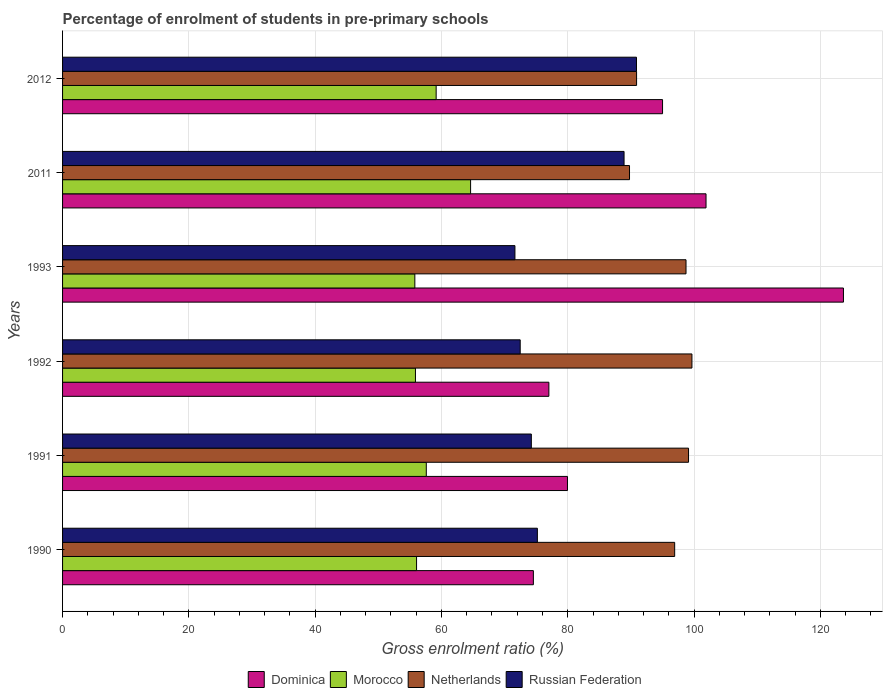How many groups of bars are there?
Give a very brief answer. 6. Are the number of bars per tick equal to the number of legend labels?
Your response must be concise. Yes. Are the number of bars on each tick of the Y-axis equal?
Give a very brief answer. Yes. How many bars are there on the 1st tick from the top?
Keep it short and to the point. 4. What is the label of the 3rd group of bars from the top?
Your answer should be compact. 1993. In how many cases, is the number of bars for a given year not equal to the number of legend labels?
Give a very brief answer. 0. What is the percentage of students enrolled in pre-primary schools in Morocco in 1991?
Make the answer very short. 57.6. Across all years, what is the maximum percentage of students enrolled in pre-primary schools in Russian Federation?
Offer a very short reply. 90.88. Across all years, what is the minimum percentage of students enrolled in pre-primary schools in Russian Federation?
Offer a very short reply. 71.64. What is the total percentage of students enrolled in pre-primary schools in Dominica in the graph?
Ensure brevity in your answer.  552.1. What is the difference between the percentage of students enrolled in pre-primary schools in Netherlands in 1990 and that in 2011?
Keep it short and to the point. 7.15. What is the difference between the percentage of students enrolled in pre-primary schools in Netherlands in 1993 and the percentage of students enrolled in pre-primary schools in Dominica in 1992?
Your answer should be very brief. 21.72. What is the average percentage of students enrolled in pre-primary schools in Dominica per year?
Offer a very short reply. 92.02. In the year 2011, what is the difference between the percentage of students enrolled in pre-primary schools in Morocco and percentage of students enrolled in pre-primary schools in Dominica?
Give a very brief answer. -37.28. What is the ratio of the percentage of students enrolled in pre-primary schools in Morocco in 1992 to that in 2011?
Your answer should be very brief. 0.86. What is the difference between the highest and the second highest percentage of students enrolled in pre-primary schools in Morocco?
Provide a succinct answer. 5.45. What is the difference between the highest and the lowest percentage of students enrolled in pre-primary schools in Dominica?
Provide a short and direct response. 49.1. In how many years, is the percentage of students enrolled in pre-primary schools in Russian Federation greater than the average percentage of students enrolled in pre-primary schools in Russian Federation taken over all years?
Make the answer very short. 2. Is the sum of the percentage of students enrolled in pre-primary schools in Russian Federation in 1993 and 2012 greater than the maximum percentage of students enrolled in pre-primary schools in Morocco across all years?
Give a very brief answer. Yes. What does the 4th bar from the top in 1992 represents?
Offer a terse response. Dominica. What does the 4th bar from the bottom in 1990 represents?
Offer a very short reply. Russian Federation. How many bars are there?
Offer a terse response. 24. What is the difference between two consecutive major ticks on the X-axis?
Keep it short and to the point. 20. Does the graph contain grids?
Your response must be concise. Yes. How many legend labels are there?
Keep it short and to the point. 4. What is the title of the graph?
Your answer should be very brief. Percentage of enrolment of students in pre-primary schools. Does "Low income" appear as one of the legend labels in the graph?
Offer a terse response. No. What is the Gross enrolment ratio (%) of Dominica in 1990?
Offer a terse response. 74.56. What is the Gross enrolment ratio (%) of Morocco in 1990?
Keep it short and to the point. 56.06. What is the Gross enrolment ratio (%) of Netherlands in 1990?
Offer a terse response. 96.93. What is the Gross enrolment ratio (%) of Russian Federation in 1990?
Your response must be concise. 75.19. What is the Gross enrolment ratio (%) of Dominica in 1991?
Your response must be concise. 79.96. What is the Gross enrolment ratio (%) of Morocco in 1991?
Provide a short and direct response. 57.6. What is the Gross enrolment ratio (%) in Netherlands in 1991?
Your response must be concise. 99.13. What is the Gross enrolment ratio (%) of Russian Federation in 1991?
Your response must be concise. 74.23. What is the Gross enrolment ratio (%) in Dominica in 1992?
Offer a terse response. 77.01. What is the Gross enrolment ratio (%) in Morocco in 1992?
Your response must be concise. 55.88. What is the Gross enrolment ratio (%) of Netherlands in 1992?
Ensure brevity in your answer.  99.67. What is the Gross enrolment ratio (%) of Russian Federation in 1992?
Offer a very short reply. 72.47. What is the Gross enrolment ratio (%) of Dominica in 1993?
Provide a short and direct response. 123.66. What is the Gross enrolment ratio (%) of Morocco in 1993?
Provide a short and direct response. 55.79. What is the Gross enrolment ratio (%) of Netherlands in 1993?
Ensure brevity in your answer.  98.73. What is the Gross enrolment ratio (%) in Russian Federation in 1993?
Give a very brief answer. 71.64. What is the Gross enrolment ratio (%) in Dominica in 2011?
Make the answer very short. 101.9. What is the Gross enrolment ratio (%) of Morocco in 2011?
Provide a short and direct response. 64.61. What is the Gross enrolment ratio (%) in Netherlands in 2011?
Provide a succinct answer. 89.78. What is the Gross enrolment ratio (%) of Russian Federation in 2011?
Your answer should be very brief. 88.92. What is the Gross enrolment ratio (%) of Dominica in 2012?
Your answer should be compact. 95.01. What is the Gross enrolment ratio (%) of Morocco in 2012?
Your answer should be very brief. 59.16. What is the Gross enrolment ratio (%) of Netherlands in 2012?
Keep it short and to the point. 90.9. What is the Gross enrolment ratio (%) of Russian Federation in 2012?
Make the answer very short. 90.88. Across all years, what is the maximum Gross enrolment ratio (%) in Dominica?
Ensure brevity in your answer.  123.66. Across all years, what is the maximum Gross enrolment ratio (%) of Morocco?
Offer a very short reply. 64.61. Across all years, what is the maximum Gross enrolment ratio (%) in Netherlands?
Offer a very short reply. 99.67. Across all years, what is the maximum Gross enrolment ratio (%) of Russian Federation?
Offer a very short reply. 90.88. Across all years, what is the minimum Gross enrolment ratio (%) in Dominica?
Your answer should be compact. 74.56. Across all years, what is the minimum Gross enrolment ratio (%) of Morocco?
Offer a terse response. 55.79. Across all years, what is the minimum Gross enrolment ratio (%) in Netherlands?
Ensure brevity in your answer.  89.78. Across all years, what is the minimum Gross enrolment ratio (%) of Russian Federation?
Your answer should be compact. 71.64. What is the total Gross enrolment ratio (%) in Dominica in the graph?
Provide a short and direct response. 552.1. What is the total Gross enrolment ratio (%) of Morocco in the graph?
Your answer should be very brief. 349.11. What is the total Gross enrolment ratio (%) in Netherlands in the graph?
Give a very brief answer. 575.14. What is the total Gross enrolment ratio (%) in Russian Federation in the graph?
Keep it short and to the point. 473.34. What is the difference between the Gross enrolment ratio (%) of Dominica in 1990 and that in 1991?
Keep it short and to the point. -5.4. What is the difference between the Gross enrolment ratio (%) in Morocco in 1990 and that in 1991?
Make the answer very short. -1.54. What is the difference between the Gross enrolment ratio (%) in Netherlands in 1990 and that in 1991?
Your answer should be compact. -2.2. What is the difference between the Gross enrolment ratio (%) in Russian Federation in 1990 and that in 1991?
Your answer should be compact. 0.96. What is the difference between the Gross enrolment ratio (%) of Dominica in 1990 and that in 1992?
Provide a succinct answer. -2.45. What is the difference between the Gross enrolment ratio (%) in Morocco in 1990 and that in 1992?
Ensure brevity in your answer.  0.18. What is the difference between the Gross enrolment ratio (%) in Netherlands in 1990 and that in 1992?
Ensure brevity in your answer.  -2.73. What is the difference between the Gross enrolment ratio (%) of Russian Federation in 1990 and that in 1992?
Your answer should be very brief. 2.72. What is the difference between the Gross enrolment ratio (%) of Dominica in 1990 and that in 1993?
Make the answer very short. -49.1. What is the difference between the Gross enrolment ratio (%) in Morocco in 1990 and that in 1993?
Keep it short and to the point. 0.27. What is the difference between the Gross enrolment ratio (%) of Netherlands in 1990 and that in 1993?
Provide a succinct answer. -1.8. What is the difference between the Gross enrolment ratio (%) of Russian Federation in 1990 and that in 1993?
Your response must be concise. 3.55. What is the difference between the Gross enrolment ratio (%) of Dominica in 1990 and that in 2011?
Your response must be concise. -27.34. What is the difference between the Gross enrolment ratio (%) in Morocco in 1990 and that in 2011?
Ensure brevity in your answer.  -8.55. What is the difference between the Gross enrolment ratio (%) in Netherlands in 1990 and that in 2011?
Provide a succinct answer. 7.15. What is the difference between the Gross enrolment ratio (%) in Russian Federation in 1990 and that in 2011?
Your response must be concise. -13.73. What is the difference between the Gross enrolment ratio (%) of Dominica in 1990 and that in 2012?
Offer a very short reply. -20.46. What is the difference between the Gross enrolment ratio (%) of Morocco in 1990 and that in 2012?
Give a very brief answer. -3.1. What is the difference between the Gross enrolment ratio (%) of Netherlands in 1990 and that in 2012?
Offer a very short reply. 6.03. What is the difference between the Gross enrolment ratio (%) in Russian Federation in 1990 and that in 2012?
Provide a short and direct response. -15.69. What is the difference between the Gross enrolment ratio (%) in Dominica in 1991 and that in 1992?
Your answer should be compact. 2.95. What is the difference between the Gross enrolment ratio (%) in Morocco in 1991 and that in 1992?
Ensure brevity in your answer.  1.72. What is the difference between the Gross enrolment ratio (%) of Netherlands in 1991 and that in 1992?
Provide a short and direct response. -0.54. What is the difference between the Gross enrolment ratio (%) of Russian Federation in 1991 and that in 1992?
Provide a succinct answer. 1.76. What is the difference between the Gross enrolment ratio (%) of Dominica in 1991 and that in 1993?
Provide a short and direct response. -43.7. What is the difference between the Gross enrolment ratio (%) in Morocco in 1991 and that in 1993?
Your response must be concise. 1.81. What is the difference between the Gross enrolment ratio (%) in Netherlands in 1991 and that in 1993?
Keep it short and to the point. 0.4. What is the difference between the Gross enrolment ratio (%) of Russian Federation in 1991 and that in 1993?
Provide a short and direct response. 2.6. What is the difference between the Gross enrolment ratio (%) in Dominica in 1991 and that in 2011?
Give a very brief answer. -21.94. What is the difference between the Gross enrolment ratio (%) of Morocco in 1991 and that in 2011?
Your answer should be compact. -7.01. What is the difference between the Gross enrolment ratio (%) in Netherlands in 1991 and that in 2011?
Offer a terse response. 9.35. What is the difference between the Gross enrolment ratio (%) of Russian Federation in 1991 and that in 2011?
Offer a very short reply. -14.68. What is the difference between the Gross enrolment ratio (%) of Dominica in 1991 and that in 2012?
Ensure brevity in your answer.  -15.06. What is the difference between the Gross enrolment ratio (%) in Morocco in 1991 and that in 2012?
Make the answer very short. -1.56. What is the difference between the Gross enrolment ratio (%) of Netherlands in 1991 and that in 2012?
Your answer should be very brief. 8.23. What is the difference between the Gross enrolment ratio (%) in Russian Federation in 1991 and that in 2012?
Offer a terse response. -16.65. What is the difference between the Gross enrolment ratio (%) of Dominica in 1992 and that in 1993?
Your response must be concise. -46.65. What is the difference between the Gross enrolment ratio (%) of Morocco in 1992 and that in 1993?
Your response must be concise. 0.09. What is the difference between the Gross enrolment ratio (%) of Netherlands in 1992 and that in 1993?
Offer a terse response. 0.94. What is the difference between the Gross enrolment ratio (%) in Russian Federation in 1992 and that in 1993?
Keep it short and to the point. 0.84. What is the difference between the Gross enrolment ratio (%) in Dominica in 1992 and that in 2011?
Make the answer very short. -24.89. What is the difference between the Gross enrolment ratio (%) in Morocco in 1992 and that in 2011?
Offer a terse response. -8.73. What is the difference between the Gross enrolment ratio (%) of Netherlands in 1992 and that in 2011?
Keep it short and to the point. 9.89. What is the difference between the Gross enrolment ratio (%) in Russian Federation in 1992 and that in 2011?
Your response must be concise. -16.45. What is the difference between the Gross enrolment ratio (%) of Dominica in 1992 and that in 2012?
Give a very brief answer. -18. What is the difference between the Gross enrolment ratio (%) of Morocco in 1992 and that in 2012?
Keep it short and to the point. -3.28. What is the difference between the Gross enrolment ratio (%) in Netherlands in 1992 and that in 2012?
Offer a very short reply. 8.77. What is the difference between the Gross enrolment ratio (%) in Russian Federation in 1992 and that in 2012?
Provide a succinct answer. -18.41. What is the difference between the Gross enrolment ratio (%) in Dominica in 1993 and that in 2011?
Ensure brevity in your answer.  21.76. What is the difference between the Gross enrolment ratio (%) in Morocco in 1993 and that in 2011?
Your answer should be very brief. -8.83. What is the difference between the Gross enrolment ratio (%) in Netherlands in 1993 and that in 2011?
Offer a terse response. 8.95. What is the difference between the Gross enrolment ratio (%) in Russian Federation in 1993 and that in 2011?
Offer a very short reply. -17.28. What is the difference between the Gross enrolment ratio (%) in Dominica in 1993 and that in 2012?
Provide a succinct answer. 28.65. What is the difference between the Gross enrolment ratio (%) in Morocco in 1993 and that in 2012?
Give a very brief answer. -3.38. What is the difference between the Gross enrolment ratio (%) of Netherlands in 1993 and that in 2012?
Offer a terse response. 7.83. What is the difference between the Gross enrolment ratio (%) of Russian Federation in 1993 and that in 2012?
Your answer should be very brief. -19.25. What is the difference between the Gross enrolment ratio (%) in Dominica in 2011 and that in 2012?
Give a very brief answer. 6.89. What is the difference between the Gross enrolment ratio (%) of Morocco in 2011 and that in 2012?
Provide a succinct answer. 5.45. What is the difference between the Gross enrolment ratio (%) of Netherlands in 2011 and that in 2012?
Your answer should be very brief. -1.12. What is the difference between the Gross enrolment ratio (%) of Russian Federation in 2011 and that in 2012?
Provide a short and direct response. -1.97. What is the difference between the Gross enrolment ratio (%) of Dominica in 1990 and the Gross enrolment ratio (%) of Morocco in 1991?
Make the answer very short. 16.96. What is the difference between the Gross enrolment ratio (%) of Dominica in 1990 and the Gross enrolment ratio (%) of Netherlands in 1991?
Your answer should be compact. -24.57. What is the difference between the Gross enrolment ratio (%) in Dominica in 1990 and the Gross enrolment ratio (%) in Russian Federation in 1991?
Your answer should be very brief. 0.32. What is the difference between the Gross enrolment ratio (%) in Morocco in 1990 and the Gross enrolment ratio (%) in Netherlands in 1991?
Give a very brief answer. -43.07. What is the difference between the Gross enrolment ratio (%) in Morocco in 1990 and the Gross enrolment ratio (%) in Russian Federation in 1991?
Keep it short and to the point. -18.17. What is the difference between the Gross enrolment ratio (%) in Netherlands in 1990 and the Gross enrolment ratio (%) in Russian Federation in 1991?
Provide a short and direct response. 22.7. What is the difference between the Gross enrolment ratio (%) in Dominica in 1990 and the Gross enrolment ratio (%) in Morocco in 1992?
Provide a short and direct response. 18.68. What is the difference between the Gross enrolment ratio (%) of Dominica in 1990 and the Gross enrolment ratio (%) of Netherlands in 1992?
Your answer should be compact. -25.11. What is the difference between the Gross enrolment ratio (%) in Dominica in 1990 and the Gross enrolment ratio (%) in Russian Federation in 1992?
Ensure brevity in your answer.  2.09. What is the difference between the Gross enrolment ratio (%) in Morocco in 1990 and the Gross enrolment ratio (%) in Netherlands in 1992?
Offer a very short reply. -43.61. What is the difference between the Gross enrolment ratio (%) in Morocco in 1990 and the Gross enrolment ratio (%) in Russian Federation in 1992?
Offer a very short reply. -16.41. What is the difference between the Gross enrolment ratio (%) of Netherlands in 1990 and the Gross enrolment ratio (%) of Russian Federation in 1992?
Keep it short and to the point. 24.46. What is the difference between the Gross enrolment ratio (%) of Dominica in 1990 and the Gross enrolment ratio (%) of Morocco in 1993?
Provide a succinct answer. 18.77. What is the difference between the Gross enrolment ratio (%) of Dominica in 1990 and the Gross enrolment ratio (%) of Netherlands in 1993?
Your response must be concise. -24.17. What is the difference between the Gross enrolment ratio (%) of Dominica in 1990 and the Gross enrolment ratio (%) of Russian Federation in 1993?
Your answer should be very brief. 2.92. What is the difference between the Gross enrolment ratio (%) in Morocco in 1990 and the Gross enrolment ratio (%) in Netherlands in 1993?
Offer a very short reply. -42.67. What is the difference between the Gross enrolment ratio (%) of Morocco in 1990 and the Gross enrolment ratio (%) of Russian Federation in 1993?
Provide a short and direct response. -15.58. What is the difference between the Gross enrolment ratio (%) in Netherlands in 1990 and the Gross enrolment ratio (%) in Russian Federation in 1993?
Your response must be concise. 25.3. What is the difference between the Gross enrolment ratio (%) of Dominica in 1990 and the Gross enrolment ratio (%) of Morocco in 2011?
Your answer should be very brief. 9.94. What is the difference between the Gross enrolment ratio (%) of Dominica in 1990 and the Gross enrolment ratio (%) of Netherlands in 2011?
Your answer should be very brief. -15.22. What is the difference between the Gross enrolment ratio (%) in Dominica in 1990 and the Gross enrolment ratio (%) in Russian Federation in 2011?
Your answer should be very brief. -14.36. What is the difference between the Gross enrolment ratio (%) of Morocco in 1990 and the Gross enrolment ratio (%) of Netherlands in 2011?
Offer a terse response. -33.72. What is the difference between the Gross enrolment ratio (%) of Morocco in 1990 and the Gross enrolment ratio (%) of Russian Federation in 2011?
Provide a short and direct response. -32.86. What is the difference between the Gross enrolment ratio (%) in Netherlands in 1990 and the Gross enrolment ratio (%) in Russian Federation in 2011?
Ensure brevity in your answer.  8.02. What is the difference between the Gross enrolment ratio (%) of Dominica in 1990 and the Gross enrolment ratio (%) of Morocco in 2012?
Offer a very short reply. 15.4. What is the difference between the Gross enrolment ratio (%) of Dominica in 1990 and the Gross enrolment ratio (%) of Netherlands in 2012?
Provide a short and direct response. -16.34. What is the difference between the Gross enrolment ratio (%) in Dominica in 1990 and the Gross enrolment ratio (%) in Russian Federation in 2012?
Make the answer very short. -16.33. What is the difference between the Gross enrolment ratio (%) in Morocco in 1990 and the Gross enrolment ratio (%) in Netherlands in 2012?
Offer a very short reply. -34.84. What is the difference between the Gross enrolment ratio (%) in Morocco in 1990 and the Gross enrolment ratio (%) in Russian Federation in 2012?
Your answer should be compact. -34.82. What is the difference between the Gross enrolment ratio (%) of Netherlands in 1990 and the Gross enrolment ratio (%) of Russian Federation in 2012?
Offer a very short reply. 6.05. What is the difference between the Gross enrolment ratio (%) in Dominica in 1991 and the Gross enrolment ratio (%) in Morocco in 1992?
Provide a succinct answer. 24.07. What is the difference between the Gross enrolment ratio (%) in Dominica in 1991 and the Gross enrolment ratio (%) in Netherlands in 1992?
Offer a very short reply. -19.71. What is the difference between the Gross enrolment ratio (%) in Dominica in 1991 and the Gross enrolment ratio (%) in Russian Federation in 1992?
Your answer should be compact. 7.49. What is the difference between the Gross enrolment ratio (%) of Morocco in 1991 and the Gross enrolment ratio (%) of Netherlands in 1992?
Your response must be concise. -42.07. What is the difference between the Gross enrolment ratio (%) in Morocco in 1991 and the Gross enrolment ratio (%) in Russian Federation in 1992?
Offer a very short reply. -14.87. What is the difference between the Gross enrolment ratio (%) in Netherlands in 1991 and the Gross enrolment ratio (%) in Russian Federation in 1992?
Keep it short and to the point. 26.66. What is the difference between the Gross enrolment ratio (%) in Dominica in 1991 and the Gross enrolment ratio (%) in Morocco in 1993?
Provide a succinct answer. 24.17. What is the difference between the Gross enrolment ratio (%) of Dominica in 1991 and the Gross enrolment ratio (%) of Netherlands in 1993?
Offer a terse response. -18.77. What is the difference between the Gross enrolment ratio (%) in Dominica in 1991 and the Gross enrolment ratio (%) in Russian Federation in 1993?
Your answer should be very brief. 8.32. What is the difference between the Gross enrolment ratio (%) of Morocco in 1991 and the Gross enrolment ratio (%) of Netherlands in 1993?
Provide a succinct answer. -41.13. What is the difference between the Gross enrolment ratio (%) in Morocco in 1991 and the Gross enrolment ratio (%) in Russian Federation in 1993?
Your answer should be very brief. -14.03. What is the difference between the Gross enrolment ratio (%) in Netherlands in 1991 and the Gross enrolment ratio (%) in Russian Federation in 1993?
Provide a short and direct response. 27.49. What is the difference between the Gross enrolment ratio (%) of Dominica in 1991 and the Gross enrolment ratio (%) of Morocco in 2011?
Offer a very short reply. 15.34. What is the difference between the Gross enrolment ratio (%) in Dominica in 1991 and the Gross enrolment ratio (%) in Netherlands in 2011?
Your response must be concise. -9.82. What is the difference between the Gross enrolment ratio (%) of Dominica in 1991 and the Gross enrolment ratio (%) of Russian Federation in 2011?
Keep it short and to the point. -8.96. What is the difference between the Gross enrolment ratio (%) of Morocco in 1991 and the Gross enrolment ratio (%) of Netherlands in 2011?
Your answer should be very brief. -32.18. What is the difference between the Gross enrolment ratio (%) of Morocco in 1991 and the Gross enrolment ratio (%) of Russian Federation in 2011?
Offer a terse response. -31.32. What is the difference between the Gross enrolment ratio (%) of Netherlands in 1991 and the Gross enrolment ratio (%) of Russian Federation in 2011?
Your answer should be very brief. 10.21. What is the difference between the Gross enrolment ratio (%) in Dominica in 1991 and the Gross enrolment ratio (%) in Morocco in 2012?
Your answer should be very brief. 20.79. What is the difference between the Gross enrolment ratio (%) in Dominica in 1991 and the Gross enrolment ratio (%) in Netherlands in 2012?
Make the answer very short. -10.94. What is the difference between the Gross enrolment ratio (%) in Dominica in 1991 and the Gross enrolment ratio (%) in Russian Federation in 2012?
Provide a succinct answer. -10.93. What is the difference between the Gross enrolment ratio (%) of Morocco in 1991 and the Gross enrolment ratio (%) of Netherlands in 2012?
Your response must be concise. -33.3. What is the difference between the Gross enrolment ratio (%) of Morocco in 1991 and the Gross enrolment ratio (%) of Russian Federation in 2012?
Keep it short and to the point. -33.28. What is the difference between the Gross enrolment ratio (%) of Netherlands in 1991 and the Gross enrolment ratio (%) of Russian Federation in 2012?
Your answer should be compact. 8.24. What is the difference between the Gross enrolment ratio (%) in Dominica in 1992 and the Gross enrolment ratio (%) in Morocco in 1993?
Your response must be concise. 21.22. What is the difference between the Gross enrolment ratio (%) in Dominica in 1992 and the Gross enrolment ratio (%) in Netherlands in 1993?
Provide a succinct answer. -21.72. What is the difference between the Gross enrolment ratio (%) of Dominica in 1992 and the Gross enrolment ratio (%) of Russian Federation in 1993?
Make the answer very short. 5.38. What is the difference between the Gross enrolment ratio (%) in Morocco in 1992 and the Gross enrolment ratio (%) in Netherlands in 1993?
Provide a short and direct response. -42.85. What is the difference between the Gross enrolment ratio (%) in Morocco in 1992 and the Gross enrolment ratio (%) in Russian Federation in 1993?
Ensure brevity in your answer.  -15.75. What is the difference between the Gross enrolment ratio (%) in Netherlands in 1992 and the Gross enrolment ratio (%) in Russian Federation in 1993?
Offer a very short reply. 28.03. What is the difference between the Gross enrolment ratio (%) in Dominica in 1992 and the Gross enrolment ratio (%) in Morocco in 2011?
Your answer should be compact. 12.4. What is the difference between the Gross enrolment ratio (%) of Dominica in 1992 and the Gross enrolment ratio (%) of Netherlands in 2011?
Your answer should be very brief. -12.77. What is the difference between the Gross enrolment ratio (%) in Dominica in 1992 and the Gross enrolment ratio (%) in Russian Federation in 2011?
Provide a succinct answer. -11.91. What is the difference between the Gross enrolment ratio (%) in Morocco in 1992 and the Gross enrolment ratio (%) in Netherlands in 2011?
Ensure brevity in your answer.  -33.9. What is the difference between the Gross enrolment ratio (%) of Morocco in 1992 and the Gross enrolment ratio (%) of Russian Federation in 2011?
Your answer should be very brief. -33.03. What is the difference between the Gross enrolment ratio (%) in Netherlands in 1992 and the Gross enrolment ratio (%) in Russian Federation in 2011?
Your answer should be very brief. 10.75. What is the difference between the Gross enrolment ratio (%) of Dominica in 1992 and the Gross enrolment ratio (%) of Morocco in 2012?
Your answer should be compact. 17.85. What is the difference between the Gross enrolment ratio (%) in Dominica in 1992 and the Gross enrolment ratio (%) in Netherlands in 2012?
Ensure brevity in your answer.  -13.89. What is the difference between the Gross enrolment ratio (%) of Dominica in 1992 and the Gross enrolment ratio (%) of Russian Federation in 2012?
Your response must be concise. -13.87. What is the difference between the Gross enrolment ratio (%) of Morocco in 1992 and the Gross enrolment ratio (%) of Netherlands in 2012?
Keep it short and to the point. -35.02. What is the difference between the Gross enrolment ratio (%) in Morocco in 1992 and the Gross enrolment ratio (%) in Russian Federation in 2012?
Provide a succinct answer. -35. What is the difference between the Gross enrolment ratio (%) in Netherlands in 1992 and the Gross enrolment ratio (%) in Russian Federation in 2012?
Provide a short and direct response. 8.78. What is the difference between the Gross enrolment ratio (%) of Dominica in 1993 and the Gross enrolment ratio (%) of Morocco in 2011?
Ensure brevity in your answer.  59.05. What is the difference between the Gross enrolment ratio (%) of Dominica in 1993 and the Gross enrolment ratio (%) of Netherlands in 2011?
Give a very brief answer. 33.88. What is the difference between the Gross enrolment ratio (%) of Dominica in 1993 and the Gross enrolment ratio (%) of Russian Federation in 2011?
Offer a terse response. 34.74. What is the difference between the Gross enrolment ratio (%) in Morocco in 1993 and the Gross enrolment ratio (%) in Netherlands in 2011?
Your answer should be compact. -33.99. What is the difference between the Gross enrolment ratio (%) of Morocco in 1993 and the Gross enrolment ratio (%) of Russian Federation in 2011?
Make the answer very short. -33.13. What is the difference between the Gross enrolment ratio (%) of Netherlands in 1993 and the Gross enrolment ratio (%) of Russian Federation in 2011?
Provide a short and direct response. 9.81. What is the difference between the Gross enrolment ratio (%) of Dominica in 1993 and the Gross enrolment ratio (%) of Morocco in 2012?
Your response must be concise. 64.5. What is the difference between the Gross enrolment ratio (%) in Dominica in 1993 and the Gross enrolment ratio (%) in Netherlands in 2012?
Offer a very short reply. 32.76. What is the difference between the Gross enrolment ratio (%) of Dominica in 1993 and the Gross enrolment ratio (%) of Russian Federation in 2012?
Your answer should be very brief. 32.78. What is the difference between the Gross enrolment ratio (%) in Morocco in 1993 and the Gross enrolment ratio (%) in Netherlands in 2012?
Make the answer very short. -35.11. What is the difference between the Gross enrolment ratio (%) of Morocco in 1993 and the Gross enrolment ratio (%) of Russian Federation in 2012?
Give a very brief answer. -35.1. What is the difference between the Gross enrolment ratio (%) of Netherlands in 1993 and the Gross enrolment ratio (%) of Russian Federation in 2012?
Ensure brevity in your answer.  7.85. What is the difference between the Gross enrolment ratio (%) of Dominica in 2011 and the Gross enrolment ratio (%) of Morocco in 2012?
Provide a short and direct response. 42.74. What is the difference between the Gross enrolment ratio (%) in Dominica in 2011 and the Gross enrolment ratio (%) in Netherlands in 2012?
Your answer should be very brief. 11. What is the difference between the Gross enrolment ratio (%) in Dominica in 2011 and the Gross enrolment ratio (%) in Russian Federation in 2012?
Offer a terse response. 11.01. What is the difference between the Gross enrolment ratio (%) of Morocco in 2011 and the Gross enrolment ratio (%) of Netherlands in 2012?
Your response must be concise. -26.28. What is the difference between the Gross enrolment ratio (%) in Morocco in 2011 and the Gross enrolment ratio (%) in Russian Federation in 2012?
Keep it short and to the point. -26.27. What is the difference between the Gross enrolment ratio (%) of Netherlands in 2011 and the Gross enrolment ratio (%) of Russian Federation in 2012?
Give a very brief answer. -1.1. What is the average Gross enrolment ratio (%) of Dominica per year?
Provide a succinct answer. 92.02. What is the average Gross enrolment ratio (%) in Morocco per year?
Provide a succinct answer. 58.18. What is the average Gross enrolment ratio (%) of Netherlands per year?
Offer a very short reply. 95.86. What is the average Gross enrolment ratio (%) in Russian Federation per year?
Your answer should be very brief. 78.89. In the year 1990, what is the difference between the Gross enrolment ratio (%) in Dominica and Gross enrolment ratio (%) in Morocco?
Offer a very short reply. 18.5. In the year 1990, what is the difference between the Gross enrolment ratio (%) of Dominica and Gross enrolment ratio (%) of Netherlands?
Give a very brief answer. -22.38. In the year 1990, what is the difference between the Gross enrolment ratio (%) in Dominica and Gross enrolment ratio (%) in Russian Federation?
Your response must be concise. -0.63. In the year 1990, what is the difference between the Gross enrolment ratio (%) of Morocco and Gross enrolment ratio (%) of Netherlands?
Offer a very short reply. -40.87. In the year 1990, what is the difference between the Gross enrolment ratio (%) of Morocco and Gross enrolment ratio (%) of Russian Federation?
Ensure brevity in your answer.  -19.13. In the year 1990, what is the difference between the Gross enrolment ratio (%) in Netherlands and Gross enrolment ratio (%) in Russian Federation?
Provide a short and direct response. 21.74. In the year 1991, what is the difference between the Gross enrolment ratio (%) in Dominica and Gross enrolment ratio (%) in Morocco?
Keep it short and to the point. 22.36. In the year 1991, what is the difference between the Gross enrolment ratio (%) of Dominica and Gross enrolment ratio (%) of Netherlands?
Give a very brief answer. -19.17. In the year 1991, what is the difference between the Gross enrolment ratio (%) of Dominica and Gross enrolment ratio (%) of Russian Federation?
Ensure brevity in your answer.  5.72. In the year 1991, what is the difference between the Gross enrolment ratio (%) of Morocco and Gross enrolment ratio (%) of Netherlands?
Your answer should be very brief. -41.53. In the year 1991, what is the difference between the Gross enrolment ratio (%) of Morocco and Gross enrolment ratio (%) of Russian Federation?
Offer a terse response. -16.63. In the year 1991, what is the difference between the Gross enrolment ratio (%) in Netherlands and Gross enrolment ratio (%) in Russian Federation?
Your response must be concise. 24.89. In the year 1992, what is the difference between the Gross enrolment ratio (%) in Dominica and Gross enrolment ratio (%) in Morocco?
Provide a succinct answer. 21.13. In the year 1992, what is the difference between the Gross enrolment ratio (%) of Dominica and Gross enrolment ratio (%) of Netherlands?
Your answer should be compact. -22.66. In the year 1992, what is the difference between the Gross enrolment ratio (%) in Dominica and Gross enrolment ratio (%) in Russian Federation?
Provide a succinct answer. 4.54. In the year 1992, what is the difference between the Gross enrolment ratio (%) of Morocco and Gross enrolment ratio (%) of Netherlands?
Keep it short and to the point. -43.78. In the year 1992, what is the difference between the Gross enrolment ratio (%) of Morocco and Gross enrolment ratio (%) of Russian Federation?
Make the answer very short. -16.59. In the year 1992, what is the difference between the Gross enrolment ratio (%) in Netherlands and Gross enrolment ratio (%) in Russian Federation?
Provide a short and direct response. 27.2. In the year 1993, what is the difference between the Gross enrolment ratio (%) in Dominica and Gross enrolment ratio (%) in Morocco?
Make the answer very short. 67.87. In the year 1993, what is the difference between the Gross enrolment ratio (%) in Dominica and Gross enrolment ratio (%) in Netherlands?
Offer a very short reply. 24.93. In the year 1993, what is the difference between the Gross enrolment ratio (%) in Dominica and Gross enrolment ratio (%) in Russian Federation?
Provide a succinct answer. 52.02. In the year 1993, what is the difference between the Gross enrolment ratio (%) in Morocco and Gross enrolment ratio (%) in Netherlands?
Offer a terse response. -42.94. In the year 1993, what is the difference between the Gross enrolment ratio (%) in Morocco and Gross enrolment ratio (%) in Russian Federation?
Offer a terse response. -15.85. In the year 1993, what is the difference between the Gross enrolment ratio (%) of Netherlands and Gross enrolment ratio (%) of Russian Federation?
Ensure brevity in your answer.  27.09. In the year 2011, what is the difference between the Gross enrolment ratio (%) of Dominica and Gross enrolment ratio (%) of Morocco?
Offer a very short reply. 37.28. In the year 2011, what is the difference between the Gross enrolment ratio (%) in Dominica and Gross enrolment ratio (%) in Netherlands?
Your response must be concise. 12.12. In the year 2011, what is the difference between the Gross enrolment ratio (%) in Dominica and Gross enrolment ratio (%) in Russian Federation?
Your response must be concise. 12.98. In the year 2011, what is the difference between the Gross enrolment ratio (%) in Morocco and Gross enrolment ratio (%) in Netherlands?
Your answer should be very brief. -25.17. In the year 2011, what is the difference between the Gross enrolment ratio (%) in Morocco and Gross enrolment ratio (%) in Russian Federation?
Give a very brief answer. -24.3. In the year 2011, what is the difference between the Gross enrolment ratio (%) of Netherlands and Gross enrolment ratio (%) of Russian Federation?
Your answer should be compact. 0.86. In the year 2012, what is the difference between the Gross enrolment ratio (%) in Dominica and Gross enrolment ratio (%) in Morocco?
Give a very brief answer. 35.85. In the year 2012, what is the difference between the Gross enrolment ratio (%) of Dominica and Gross enrolment ratio (%) of Netherlands?
Offer a very short reply. 4.11. In the year 2012, what is the difference between the Gross enrolment ratio (%) in Dominica and Gross enrolment ratio (%) in Russian Federation?
Your answer should be very brief. 4.13. In the year 2012, what is the difference between the Gross enrolment ratio (%) in Morocco and Gross enrolment ratio (%) in Netherlands?
Ensure brevity in your answer.  -31.74. In the year 2012, what is the difference between the Gross enrolment ratio (%) in Morocco and Gross enrolment ratio (%) in Russian Federation?
Ensure brevity in your answer.  -31.72. In the year 2012, what is the difference between the Gross enrolment ratio (%) of Netherlands and Gross enrolment ratio (%) of Russian Federation?
Offer a terse response. 0.01. What is the ratio of the Gross enrolment ratio (%) of Dominica in 1990 to that in 1991?
Keep it short and to the point. 0.93. What is the ratio of the Gross enrolment ratio (%) in Morocco in 1990 to that in 1991?
Provide a succinct answer. 0.97. What is the ratio of the Gross enrolment ratio (%) of Netherlands in 1990 to that in 1991?
Your answer should be compact. 0.98. What is the ratio of the Gross enrolment ratio (%) of Russian Federation in 1990 to that in 1991?
Your response must be concise. 1.01. What is the ratio of the Gross enrolment ratio (%) in Dominica in 1990 to that in 1992?
Your answer should be very brief. 0.97. What is the ratio of the Gross enrolment ratio (%) in Netherlands in 1990 to that in 1992?
Make the answer very short. 0.97. What is the ratio of the Gross enrolment ratio (%) in Russian Federation in 1990 to that in 1992?
Give a very brief answer. 1.04. What is the ratio of the Gross enrolment ratio (%) of Dominica in 1990 to that in 1993?
Ensure brevity in your answer.  0.6. What is the ratio of the Gross enrolment ratio (%) in Morocco in 1990 to that in 1993?
Offer a terse response. 1. What is the ratio of the Gross enrolment ratio (%) of Netherlands in 1990 to that in 1993?
Make the answer very short. 0.98. What is the ratio of the Gross enrolment ratio (%) in Russian Federation in 1990 to that in 1993?
Your answer should be very brief. 1.05. What is the ratio of the Gross enrolment ratio (%) in Dominica in 1990 to that in 2011?
Your answer should be very brief. 0.73. What is the ratio of the Gross enrolment ratio (%) in Morocco in 1990 to that in 2011?
Ensure brevity in your answer.  0.87. What is the ratio of the Gross enrolment ratio (%) of Netherlands in 1990 to that in 2011?
Offer a very short reply. 1.08. What is the ratio of the Gross enrolment ratio (%) in Russian Federation in 1990 to that in 2011?
Ensure brevity in your answer.  0.85. What is the ratio of the Gross enrolment ratio (%) of Dominica in 1990 to that in 2012?
Offer a very short reply. 0.78. What is the ratio of the Gross enrolment ratio (%) in Morocco in 1990 to that in 2012?
Offer a terse response. 0.95. What is the ratio of the Gross enrolment ratio (%) in Netherlands in 1990 to that in 2012?
Your response must be concise. 1.07. What is the ratio of the Gross enrolment ratio (%) in Russian Federation in 1990 to that in 2012?
Offer a very short reply. 0.83. What is the ratio of the Gross enrolment ratio (%) in Dominica in 1991 to that in 1992?
Ensure brevity in your answer.  1.04. What is the ratio of the Gross enrolment ratio (%) of Morocco in 1991 to that in 1992?
Keep it short and to the point. 1.03. What is the ratio of the Gross enrolment ratio (%) of Russian Federation in 1991 to that in 1992?
Offer a terse response. 1.02. What is the ratio of the Gross enrolment ratio (%) of Dominica in 1991 to that in 1993?
Your answer should be very brief. 0.65. What is the ratio of the Gross enrolment ratio (%) in Morocco in 1991 to that in 1993?
Your response must be concise. 1.03. What is the ratio of the Gross enrolment ratio (%) in Netherlands in 1991 to that in 1993?
Keep it short and to the point. 1. What is the ratio of the Gross enrolment ratio (%) of Russian Federation in 1991 to that in 1993?
Your answer should be very brief. 1.04. What is the ratio of the Gross enrolment ratio (%) of Dominica in 1991 to that in 2011?
Provide a succinct answer. 0.78. What is the ratio of the Gross enrolment ratio (%) of Morocco in 1991 to that in 2011?
Make the answer very short. 0.89. What is the ratio of the Gross enrolment ratio (%) of Netherlands in 1991 to that in 2011?
Your answer should be compact. 1.1. What is the ratio of the Gross enrolment ratio (%) of Russian Federation in 1991 to that in 2011?
Provide a short and direct response. 0.83. What is the ratio of the Gross enrolment ratio (%) in Dominica in 1991 to that in 2012?
Give a very brief answer. 0.84. What is the ratio of the Gross enrolment ratio (%) of Morocco in 1991 to that in 2012?
Keep it short and to the point. 0.97. What is the ratio of the Gross enrolment ratio (%) of Netherlands in 1991 to that in 2012?
Give a very brief answer. 1.09. What is the ratio of the Gross enrolment ratio (%) of Russian Federation in 1991 to that in 2012?
Make the answer very short. 0.82. What is the ratio of the Gross enrolment ratio (%) of Dominica in 1992 to that in 1993?
Your response must be concise. 0.62. What is the ratio of the Gross enrolment ratio (%) in Morocco in 1992 to that in 1993?
Your response must be concise. 1. What is the ratio of the Gross enrolment ratio (%) of Netherlands in 1992 to that in 1993?
Your response must be concise. 1.01. What is the ratio of the Gross enrolment ratio (%) of Russian Federation in 1992 to that in 1993?
Offer a terse response. 1.01. What is the ratio of the Gross enrolment ratio (%) of Dominica in 1992 to that in 2011?
Make the answer very short. 0.76. What is the ratio of the Gross enrolment ratio (%) of Morocco in 1992 to that in 2011?
Your answer should be compact. 0.86. What is the ratio of the Gross enrolment ratio (%) in Netherlands in 1992 to that in 2011?
Your response must be concise. 1.11. What is the ratio of the Gross enrolment ratio (%) in Russian Federation in 1992 to that in 2011?
Provide a short and direct response. 0.81. What is the ratio of the Gross enrolment ratio (%) in Dominica in 1992 to that in 2012?
Your answer should be very brief. 0.81. What is the ratio of the Gross enrolment ratio (%) of Morocco in 1992 to that in 2012?
Provide a short and direct response. 0.94. What is the ratio of the Gross enrolment ratio (%) in Netherlands in 1992 to that in 2012?
Your answer should be very brief. 1.1. What is the ratio of the Gross enrolment ratio (%) in Russian Federation in 1992 to that in 2012?
Make the answer very short. 0.8. What is the ratio of the Gross enrolment ratio (%) in Dominica in 1993 to that in 2011?
Keep it short and to the point. 1.21. What is the ratio of the Gross enrolment ratio (%) of Morocco in 1993 to that in 2011?
Make the answer very short. 0.86. What is the ratio of the Gross enrolment ratio (%) of Netherlands in 1993 to that in 2011?
Provide a succinct answer. 1.1. What is the ratio of the Gross enrolment ratio (%) in Russian Federation in 1993 to that in 2011?
Your answer should be compact. 0.81. What is the ratio of the Gross enrolment ratio (%) of Dominica in 1993 to that in 2012?
Your answer should be very brief. 1.3. What is the ratio of the Gross enrolment ratio (%) in Morocco in 1993 to that in 2012?
Provide a succinct answer. 0.94. What is the ratio of the Gross enrolment ratio (%) in Netherlands in 1993 to that in 2012?
Your answer should be compact. 1.09. What is the ratio of the Gross enrolment ratio (%) in Russian Federation in 1993 to that in 2012?
Keep it short and to the point. 0.79. What is the ratio of the Gross enrolment ratio (%) in Dominica in 2011 to that in 2012?
Provide a succinct answer. 1.07. What is the ratio of the Gross enrolment ratio (%) in Morocco in 2011 to that in 2012?
Provide a short and direct response. 1.09. What is the ratio of the Gross enrolment ratio (%) in Netherlands in 2011 to that in 2012?
Your answer should be very brief. 0.99. What is the ratio of the Gross enrolment ratio (%) in Russian Federation in 2011 to that in 2012?
Provide a succinct answer. 0.98. What is the difference between the highest and the second highest Gross enrolment ratio (%) in Dominica?
Ensure brevity in your answer.  21.76. What is the difference between the highest and the second highest Gross enrolment ratio (%) in Morocco?
Your answer should be very brief. 5.45. What is the difference between the highest and the second highest Gross enrolment ratio (%) of Netherlands?
Provide a succinct answer. 0.54. What is the difference between the highest and the second highest Gross enrolment ratio (%) in Russian Federation?
Your answer should be compact. 1.97. What is the difference between the highest and the lowest Gross enrolment ratio (%) of Dominica?
Provide a succinct answer. 49.1. What is the difference between the highest and the lowest Gross enrolment ratio (%) in Morocco?
Your answer should be compact. 8.83. What is the difference between the highest and the lowest Gross enrolment ratio (%) of Netherlands?
Offer a very short reply. 9.89. What is the difference between the highest and the lowest Gross enrolment ratio (%) in Russian Federation?
Provide a short and direct response. 19.25. 